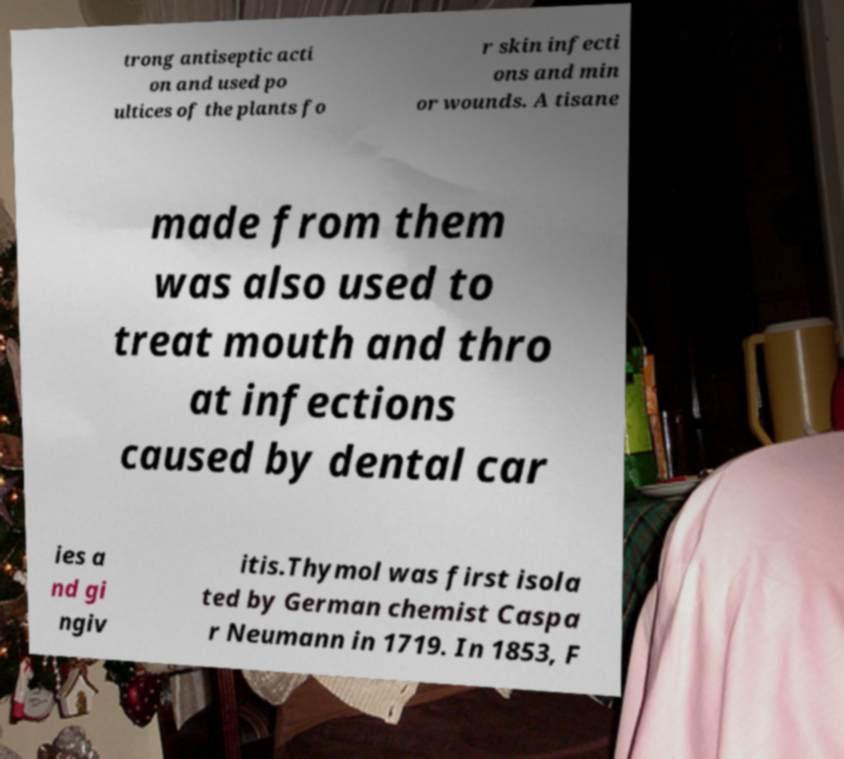For documentation purposes, I need the text within this image transcribed. Could you provide that? trong antiseptic acti on and used po ultices of the plants fo r skin infecti ons and min or wounds. A tisane made from them was also used to treat mouth and thro at infections caused by dental car ies a nd gi ngiv itis.Thymol was first isola ted by German chemist Caspa r Neumann in 1719. In 1853, F 